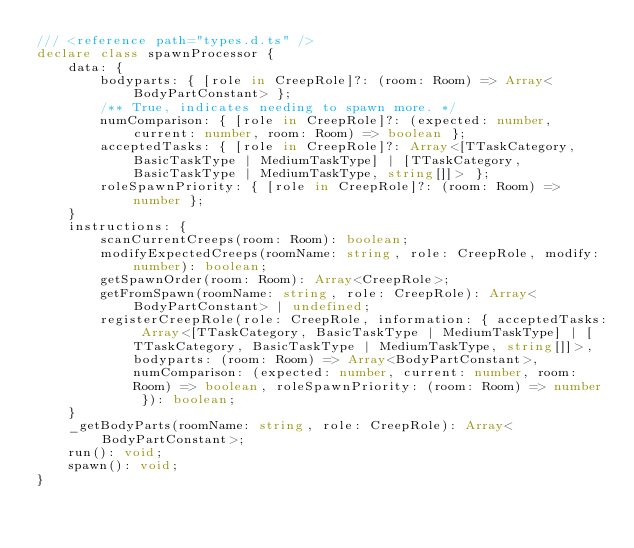Convert code to text. <code><loc_0><loc_0><loc_500><loc_500><_TypeScript_>/// <reference path="types.d.ts" />
declare class spawnProcessor {
	data: {
		bodyparts: { [role in CreepRole]?: (room: Room) => Array<BodyPartConstant> };
		/** True, indicates needing to spawn more. */
		numComparison: { [role in CreepRole]?: (expected: number, current: number, room: Room) => boolean };
		acceptedTasks: { [role in CreepRole]?: Array<[TTaskCategory, BasicTaskType | MediumTaskType] | [TTaskCategory, BasicTaskType | MediumTaskType, string[]]> };
		roleSpawnPriority: { [role in CreepRole]?: (room: Room) => number };
	}
	instructions: {
		scanCurrentCreeps(room: Room): boolean;
		modifyExpectedCreeps(roomName: string, role: CreepRole, modify: number): boolean;
		getSpawnOrder(room: Room): Array<CreepRole>;
		getFromSpawn(roomName: string, role: CreepRole): Array<BodyPartConstant> | undefined;
		registerCreepRole(role: CreepRole, information: { acceptedTasks: Array<[TTaskCategory, BasicTaskType | MediumTaskType] | [TTaskCategory, BasicTaskType | MediumTaskType, string[]]>, bodyparts: (room: Room) => Array<BodyPartConstant>, numComparison: (expected: number, current: number, room: Room) => boolean, roleSpawnPriority: (room: Room) => number }): boolean;
	}
	_getBodyParts(roomName: string, role: CreepRole): Array<BodyPartConstant>;
	run(): void;
	spawn(): void;
}
</code> 